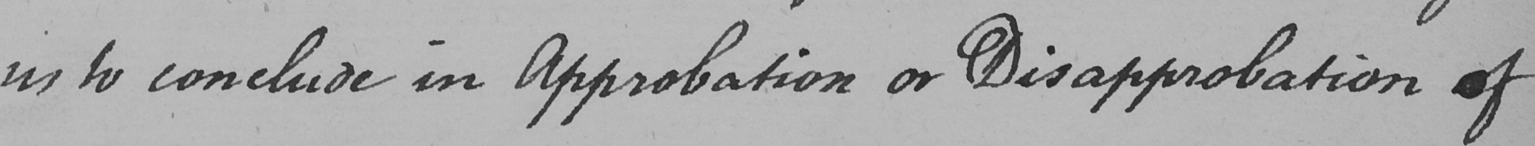What is written in this line of handwriting? us to conclude in Approbation or Disapprobation of 